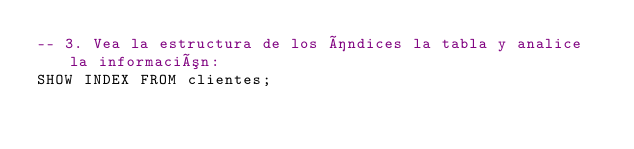Convert code to text. <code><loc_0><loc_0><loc_500><loc_500><_SQL_>-- 3. Vea la estructura de los índices la tabla y analice la información:
SHOW INDEX FROM clientes;
</code> 